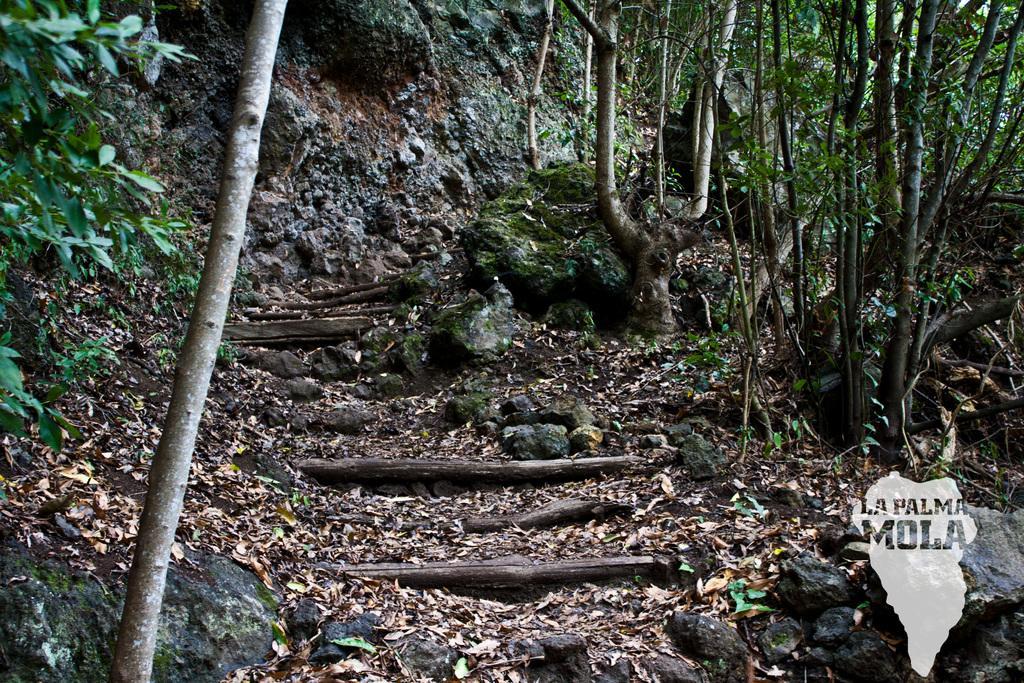How would you summarize this image in a sentence or two? This picture is taken in a forest, where we can see trees, rocks. Leafs and sticks on the round. 